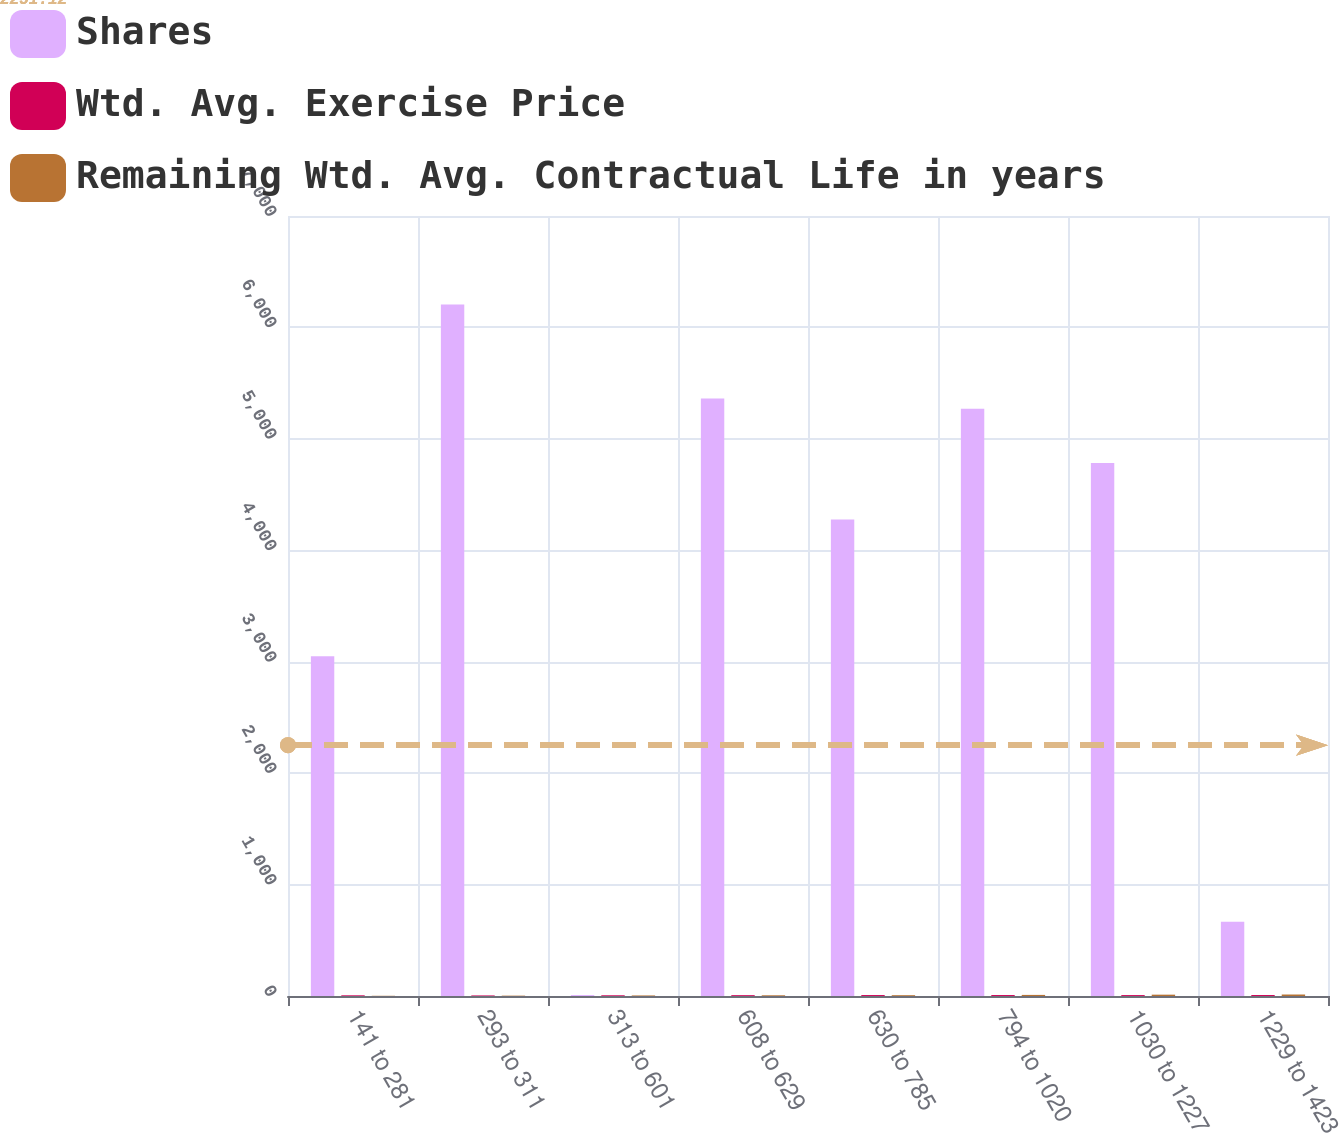<chart> <loc_0><loc_0><loc_500><loc_500><stacked_bar_chart><ecel><fcel>141 to 281<fcel>293 to 311<fcel>313 to 601<fcel>608 to 629<fcel>630 to 785<fcel>794 to 1020<fcel>1030 to 1227<fcel>1229 to 1423<nl><fcel>Shares<fcel>3048<fcel>6205<fcel>8.5<fcel>5363<fcel>4277<fcel>5270<fcel>4783<fcel>666<nl><fcel>Wtd. Avg. Exercise Price<fcel>6.08<fcel>5<fcel>6.37<fcel>7.45<fcel>8.44<fcel>8.5<fcel>8.11<fcel>8.68<nl><fcel>Remaining Wtd. Avg. Contractual Life in years<fcel>1.88<fcel>3.11<fcel>4.89<fcel>6.25<fcel>7.19<fcel>9.79<fcel>11.97<fcel>13.36<nl></chart> 